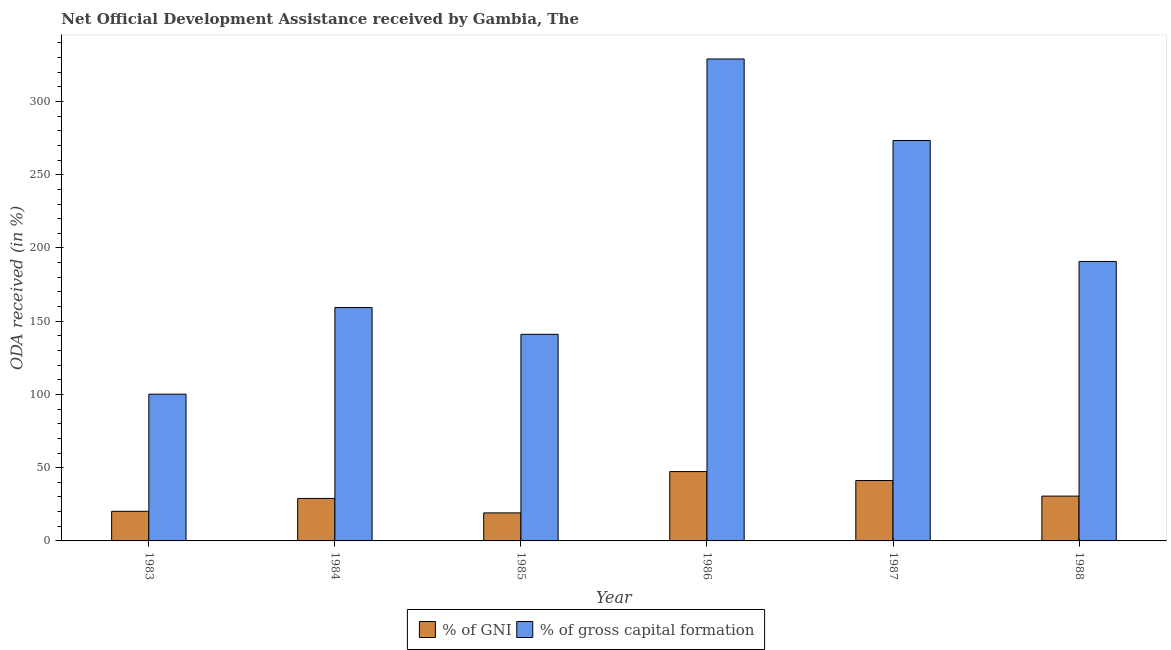Are the number of bars per tick equal to the number of legend labels?
Ensure brevity in your answer.  Yes. How many bars are there on the 2nd tick from the right?
Offer a very short reply. 2. What is the oda received as percentage of gross capital formation in 1988?
Provide a short and direct response. 190.8. Across all years, what is the maximum oda received as percentage of gni?
Keep it short and to the point. 47.34. Across all years, what is the minimum oda received as percentage of gni?
Provide a short and direct response. 19.14. What is the total oda received as percentage of gni in the graph?
Keep it short and to the point. 187.55. What is the difference between the oda received as percentage of gni in 1983 and that in 1987?
Ensure brevity in your answer.  -21.01. What is the difference between the oda received as percentage of gni in 1987 and the oda received as percentage of gross capital formation in 1983?
Your answer should be compact. 21.01. What is the average oda received as percentage of gross capital formation per year?
Provide a succinct answer. 198.97. In the year 1984, what is the difference between the oda received as percentage of gross capital formation and oda received as percentage of gni?
Keep it short and to the point. 0. What is the ratio of the oda received as percentage of gross capital formation in 1983 to that in 1984?
Your answer should be very brief. 0.63. What is the difference between the highest and the second highest oda received as percentage of gross capital formation?
Your response must be concise. 55.68. What is the difference between the highest and the lowest oda received as percentage of gni?
Your response must be concise. 28.2. In how many years, is the oda received as percentage of gross capital formation greater than the average oda received as percentage of gross capital formation taken over all years?
Keep it short and to the point. 2. What does the 1st bar from the left in 1983 represents?
Ensure brevity in your answer.  % of GNI. What does the 1st bar from the right in 1986 represents?
Your answer should be very brief. % of gross capital formation. How many years are there in the graph?
Offer a very short reply. 6. What is the difference between two consecutive major ticks on the Y-axis?
Provide a short and direct response. 50. Are the values on the major ticks of Y-axis written in scientific E-notation?
Provide a succinct answer. No. Does the graph contain any zero values?
Make the answer very short. No. Does the graph contain grids?
Ensure brevity in your answer.  No. How many legend labels are there?
Give a very brief answer. 2. What is the title of the graph?
Offer a terse response. Net Official Development Assistance received by Gambia, The. What is the label or title of the X-axis?
Keep it short and to the point. Year. What is the label or title of the Y-axis?
Your response must be concise. ODA received (in %). What is the ODA received (in %) of % of GNI in 1983?
Your answer should be compact. 20.22. What is the ODA received (in %) of % of gross capital formation in 1983?
Ensure brevity in your answer.  100.18. What is the ODA received (in %) in % of GNI in 1984?
Your answer should be very brief. 29.01. What is the ODA received (in %) in % of gross capital formation in 1984?
Your response must be concise. 159.34. What is the ODA received (in %) in % of GNI in 1985?
Provide a short and direct response. 19.14. What is the ODA received (in %) of % of gross capital formation in 1985?
Ensure brevity in your answer.  141.07. What is the ODA received (in %) in % of GNI in 1986?
Provide a short and direct response. 47.34. What is the ODA received (in %) in % of gross capital formation in 1986?
Your answer should be compact. 329.05. What is the ODA received (in %) in % of GNI in 1987?
Give a very brief answer. 41.24. What is the ODA received (in %) in % of gross capital formation in 1987?
Give a very brief answer. 273.37. What is the ODA received (in %) in % of GNI in 1988?
Offer a very short reply. 30.6. What is the ODA received (in %) in % of gross capital formation in 1988?
Make the answer very short. 190.8. Across all years, what is the maximum ODA received (in %) in % of GNI?
Offer a terse response. 47.34. Across all years, what is the maximum ODA received (in %) of % of gross capital formation?
Your answer should be compact. 329.05. Across all years, what is the minimum ODA received (in %) in % of GNI?
Provide a short and direct response. 19.14. Across all years, what is the minimum ODA received (in %) in % of gross capital formation?
Provide a short and direct response. 100.18. What is the total ODA received (in %) of % of GNI in the graph?
Provide a short and direct response. 187.55. What is the total ODA received (in %) in % of gross capital formation in the graph?
Offer a very short reply. 1193.82. What is the difference between the ODA received (in %) in % of GNI in 1983 and that in 1984?
Give a very brief answer. -8.79. What is the difference between the ODA received (in %) in % of gross capital formation in 1983 and that in 1984?
Make the answer very short. -59.16. What is the difference between the ODA received (in %) of % of GNI in 1983 and that in 1985?
Your response must be concise. 1.08. What is the difference between the ODA received (in %) of % of gross capital formation in 1983 and that in 1985?
Keep it short and to the point. -40.89. What is the difference between the ODA received (in %) in % of GNI in 1983 and that in 1986?
Keep it short and to the point. -27.12. What is the difference between the ODA received (in %) in % of gross capital formation in 1983 and that in 1986?
Offer a very short reply. -228.87. What is the difference between the ODA received (in %) in % of GNI in 1983 and that in 1987?
Your response must be concise. -21.01. What is the difference between the ODA received (in %) of % of gross capital formation in 1983 and that in 1987?
Give a very brief answer. -173.18. What is the difference between the ODA received (in %) in % of GNI in 1983 and that in 1988?
Ensure brevity in your answer.  -10.38. What is the difference between the ODA received (in %) in % of gross capital formation in 1983 and that in 1988?
Keep it short and to the point. -90.61. What is the difference between the ODA received (in %) of % of GNI in 1984 and that in 1985?
Provide a succinct answer. 9.87. What is the difference between the ODA received (in %) of % of gross capital formation in 1984 and that in 1985?
Your answer should be very brief. 18.27. What is the difference between the ODA received (in %) in % of GNI in 1984 and that in 1986?
Offer a very short reply. -18.33. What is the difference between the ODA received (in %) in % of gross capital formation in 1984 and that in 1986?
Your answer should be very brief. -169.71. What is the difference between the ODA received (in %) of % of GNI in 1984 and that in 1987?
Offer a very short reply. -12.23. What is the difference between the ODA received (in %) in % of gross capital formation in 1984 and that in 1987?
Provide a short and direct response. -114.03. What is the difference between the ODA received (in %) of % of GNI in 1984 and that in 1988?
Your response must be concise. -1.59. What is the difference between the ODA received (in %) of % of gross capital formation in 1984 and that in 1988?
Your answer should be very brief. -31.46. What is the difference between the ODA received (in %) in % of GNI in 1985 and that in 1986?
Provide a short and direct response. -28.2. What is the difference between the ODA received (in %) of % of gross capital formation in 1985 and that in 1986?
Provide a succinct answer. -187.98. What is the difference between the ODA received (in %) of % of GNI in 1985 and that in 1987?
Ensure brevity in your answer.  -22.1. What is the difference between the ODA received (in %) in % of gross capital formation in 1985 and that in 1987?
Make the answer very short. -132.3. What is the difference between the ODA received (in %) of % of GNI in 1985 and that in 1988?
Make the answer very short. -11.46. What is the difference between the ODA received (in %) of % of gross capital formation in 1985 and that in 1988?
Offer a terse response. -49.73. What is the difference between the ODA received (in %) in % of GNI in 1986 and that in 1987?
Your answer should be very brief. 6.1. What is the difference between the ODA received (in %) in % of gross capital formation in 1986 and that in 1987?
Offer a terse response. 55.68. What is the difference between the ODA received (in %) in % of GNI in 1986 and that in 1988?
Offer a very short reply. 16.73. What is the difference between the ODA received (in %) of % of gross capital formation in 1986 and that in 1988?
Offer a very short reply. 138.25. What is the difference between the ODA received (in %) in % of GNI in 1987 and that in 1988?
Ensure brevity in your answer.  10.63. What is the difference between the ODA received (in %) of % of gross capital formation in 1987 and that in 1988?
Provide a short and direct response. 82.57. What is the difference between the ODA received (in %) in % of GNI in 1983 and the ODA received (in %) in % of gross capital formation in 1984?
Your response must be concise. -139.12. What is the difference between the ODA received (in %) in % of GNI in 1983 and the ODA received (in %) in % of gross capital formation in 1985?
Ensure brevity in your answer.  -120.85. What is the difference between the ODA received (in %) of % of GNI in 1983 and the ODA received (in %) of % of gross capital formation in 1986?
Make the answer very short. -308.83. What is the difference between the ODA received (in %) of % of GNI in 1983 and the ODA received (in %) of % of gross capital formation in 1987?
Provide a short and direct response. -253.15. What is the difference between the ODA received (in %) in % of GNI in 1983 and the ODA received (in %) in % of gross capital formation in 1988?
Give a very brief answer. -170.57. What is the difference between the ODA received (in %) of % of GNI in 1984 and the ODA received (in %) of % of gross capital formation in 1985?
Make the answer very short. -112.06. What is the difference between the ODA received (in %) in % of GNI in 1984 and the ODA received (in %) in % of gross capital formation in 1986?
Your answer should be very brief. -300.04. What is the difference between the ODA received (in %) of % of GNI in 1984 and the ODA received (in %) of % of gross capital formation in 1987?
Ensure brevity in your answer.  -244.36. What is the difference between the ODA received (in %) of % of GNI in 1984 and the ODA received (in %) of % of gross capital formation in 1988?
Keep it short and to the point. -161.79. What is the difference between the ODA received (in %) of % of GNI in 1985 and the ODA received (in %) of % of gross capital formation in 1986?
Give a very brief answer. -309.91. What is the difference between the ODA received (in %) of % of GNI in 1985 and the ODA received (in %) of % of gross capital formation in 1987?
Make the answer very short. -254.23. What is the difference between the ODA received (in %) of % of GNI in 1985 and the ODA received (in %) of % of gross capital formation in 1988?
Offer a very short reply. -171.66. What is the difference between the ODA received (in %) in % of GNI in 1986 and the ODA received (in %) in % of gross capital formation in 1987?
Make the answer very short. -226.03. What is the difference between the ODA received (in %) in % of GNI in 1986 and the ODA received (in %) in % of gross capital formation in 1988?
Provide a succinct answer. -143.46. What is the difference between the ODA received (in %) of % of GNI in 1987 and the ODA received (in %) of % of gross capital formation in 1988?
Make the answer very short. -149.56. What is the average ODA received (in %) in % of GNI per year?
Give a very brief answer. 31.26. What is the average ODA received (in %) in % of gross capital formation per year?
Your answer should be very brief. 198.97. In the year 1983, what is the difference between the ODA received (in %) in % of GNI and ODA received (in %) in % of gross capital formation?
Keep it short and to the point. -79.96. In the year 1984, what is the difference between the ODA received (in %) in % of GNI and ODA received (in %) in % of gross capital formation?
Your response must be concise. -130.33. In the year 1985, what is the difference between the ODA received (in %) in % of GNI and ODA received (in %) in % of gross capital formation?
Provide a short and direct response. -121.93. In the year 1986, what is the difference between the ODA received (in %) in % of GNI and ODA received (in %) in % of gross capital formation?
Your response must be concise. -281.71. In the year 1987, what is the difference between the ODA received (in %) in % of GNI and ODA received (in %) in % of gross capital formation?
Make the answer very short. -232.13. In the year 1988, what is the difference between the ODA received (in %) of % of GNI and ODA received (in %) of % of gross capital formation?
Your answer should be compact. -160.19. What is the ratio of the ODA received (in %) of % of GNI in 1983 to that in 1984?
Provide a succinct answer. 0.7. What is the ratio of the ODA received (in %) of % of gross capital formation in 1983 to that in 1984?
Your answer should be very brief. 0.63. What is the ratio of the ODA received (in %) in % of GNI in 1983 to that in 1985?
Give a very brief answer. 1.06. What is the ratio of the ODA received (in %) in % of gross capital formation in 1983 to that in 1985?
Offer a terse response. 0.71. What is the ratio of the ODA received (in %) in % of GNI in 1983 to that in 1986?
Give a very brief answer. 0.43. What is the ratio of the ODA received (in %) in % of gross capital formation in 1983 to that in 1986?
Ensure brevity in your answer.  0.3. What is the ratio of the ODA received (in %) in % of GNI in 1983 to that in 1987?
Make the answer very short. 0.49. What is the ratio of the ODA received (in %) of % of gross capital formation in 1983 to that in 1987?
Offer a very short reply. 0.37. What is the ratio of the ODA received (in %) of % of GNI in 1983 to that in 1988?
Your response must be concise. 0.66. What is the ratio of the ODA received (in %) of % of gross capital formation in 1983 to that in 1988?
Make the answer very short. 0.53. What is the ratio of the ODA received (in %) of % of GNI in 1984 to that in 1985?
Your answer should be very brief. 1.52. What is the ratio of the ODA received (in %) of % of gross capital formation in 1984 to that in 1985?
Offer a very short reply. 1.13. What is the ratio of the ODA received (in %) of % of GNI in 1984 to that in 1986?
Offer a very short reply. 0.61. What is the ratio of the ODA received (in %) of % of gross capital formation in 1984 to that in 1986?
Make the answer very short. 0.48. What is the ratio of the ODA received (in %) of % of GNI in 1984 to that in 1987?
Offer a terse response. 0.7. What is the ratio of the ODA received (in %) of % of gross capital formation in 1984 to that in 1987?
Your answer should be compact. 0.58. What is the ratio of the ODA received (in %) of % of GNI in 1984 to that in 1988?
Provide a short and direct response. 0.95. What is the ratio of the ODA received (in %) of % of gross capital formation in 1984 to that in 1988?
Keep it short and to the point. 0.84. What is the ratio of the ODA received (in %) of % of GNI in 1985 to that in 1986?
Give a very brief answer. 0.4. What is the ratio of the ODA received (in %) in % of gross capital formation in 1985 to that in 1986?
Provide a short and direct response. 0.43. What is the ratio of the ODA received (in %) of % of GNI in 1985 to that in 1987?
Provide a succinct answer. 0.46. What is the ratio of the ODA received (in %) in % of gross capital formation in 1985 to that in 1987?
Offer a very short reply. 0.52. What is the ratio of the ODA received (in %) of % of GNI in 1985 to that in 1988?
Provide a succinct answer. 0.63. What is the ratio of the ODA received (in %) in % of gross capital formation in 1985 to that in 1988?
Your answer should be very brief. 0.74. What is the ratio of the ODA received (in %) of % of GNI in 1986 to that in 1987?
Provide a short and direct response. 1.15. What is the ratio of the ODA received (in %) of % of gross capital formation in 1986 to that in 1987?
Provide a succinct answer. 1.2. What is the ratio of the ODA received (in %) in % of GNI in 1986 to that in 1988?
Give a very brief answer. 1.55. What is the ratio of the ODA received (in %) of % of gross capital formation in 1986 to that in 1988?
Your response must be concise. 1.72. What is the ratio of the ODA received (in %) of % of GNI in 1987 to that in 1988?
Your response must be concise. 1.35. What is the ratio of the ODA received (in %) of % of gross capital formation in 1987 to that in 1988?
Give a very brief answer. 1.43. What is the difference between the highest and the second highest ODA received (in %) of % of GNI?
Offer a very short reply. 6.1. What is the difference between the highest and the second highest ODA received (in %) of % of gross capital formation?
Your answer should be compact. 55.68. What is the difference between the highest and the lowest ODA received (in %) of % of GNI?
Provide a succinct answer. 28.2. What is the difference between the highest and the lowest ODA received (in %) in % of gross capital formation?
Give a very brief answer. 228.87. 